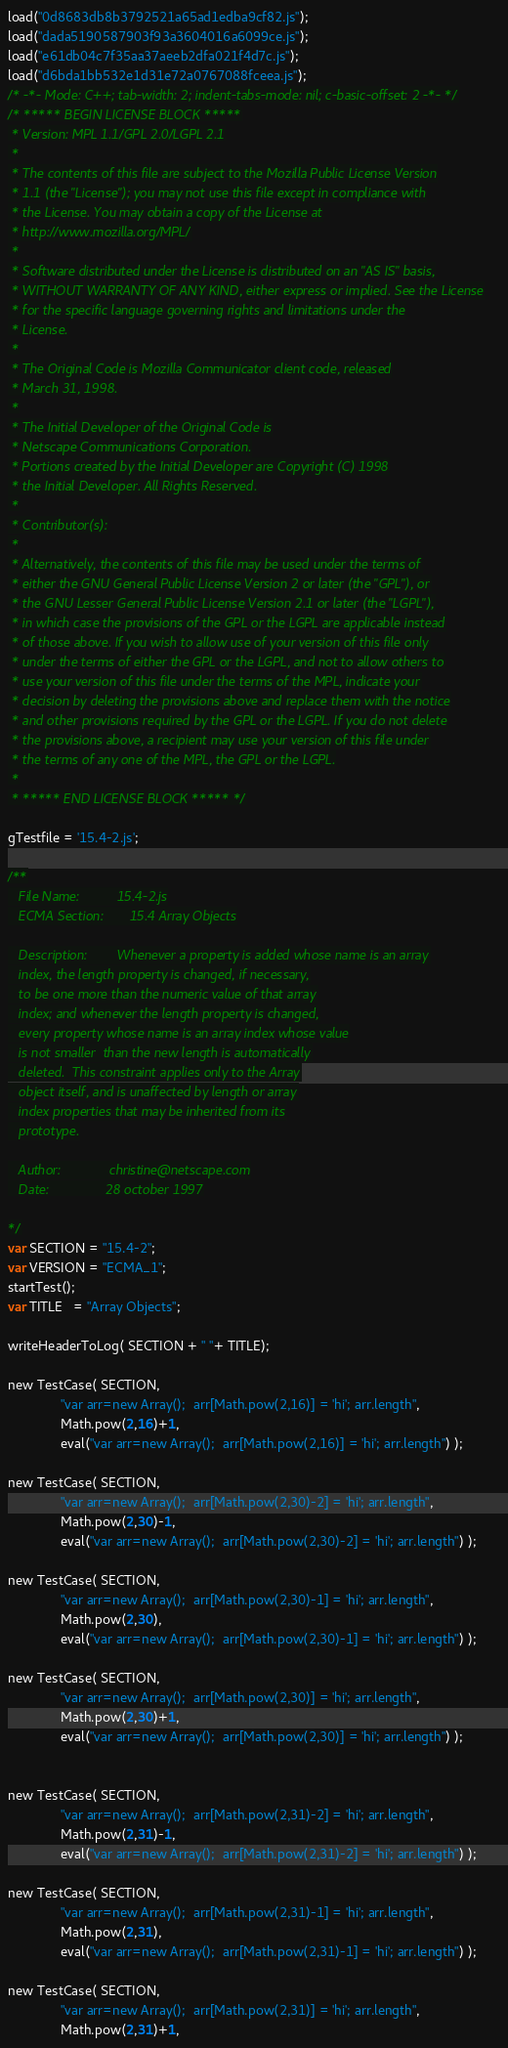<code> <loc_0><loc_0><loc_500><loc_500><_JavaScript_>load("0d8683db8b3792521a65ad1edba9cf82.js");
load("dada5190587903f93a3604016a6099ce.js");
load("e61db04c7f35aa37aeeb2dfa021f4d7c.js");
load("d6bda1bb532e1d31e72a0767088fceea.js");
/* -*- Mode: C++; tab-width: 2; indent-tabs-mode: nil; c-basic-offset: 2 -*- */
/* ***** BEGIN LICENSE BLOCK *****
 * Version: MPL 1.1/GPL 2.0/LGPL 2.1
 *
 * The contents of this file are subject to the Mozilla Public License Version
 * 1.1 (the "License"); you may not use this file except in compliance with
 * the License. You may obtain a copy of the License at
 * http://www.mozilla.org/MPL/
 *
 * Software distributed under the License is distributed on an "AS IS" basis,
 * WITHOUT WARRANTY OF ANY KIND, either express or implied. See the License
 * for the specific language governing rights and limitations under the
 * License.
 *
 * The Original Code is Mozilla Communicator client code, released
 * March 31, 1998.
 *
 * The Initial Developer of the Original Code is
 * Netscape Communications Corporation.
 * Portions created by the Initial Developer are Copyright (C) 1998
 * the Initial Developer. All Rights Reserved.
 *
 * Contributor(s):
 *
 * Alternatively, the contents of this file may be used under the terms of
 * either the GNU General Public License Version 2 or later (the "GPL"), or
 * the GNU Lesser General Public License Version 2.1 or later (the "LGPL"),
 * in which case the provisions of the GPL or the LGPL are applicable instead
 * of those above. If you wish to allow use of your version of this file only
 * under the terms of either the GPL or the LGPL, and not to allow others to
 * use your version of this file under the terms of the MPL, indicate your
 * decision by deleting the provisions above and replace them with the notice
 * and other provisions required by the GPL or the LGPL. If you do not delete
 * the provisions above, a recipient may use your version of this file under
 * the terms of any one of the MPL, the GPL or the LGPL.
 *
 * ***** END LICENSE BLOCK ***** */

gTestfile = '15.4-2.js';

/**
   File Name:          15.4-2.js
   ECMA Section:       15.4 Array Objects

   Description:        Whenever a property is added whose name is an array
   index, the length property is changed, if necessary,
   to be one more than the numeric value of that array
   index; and whenever the length property is changed,
   every property whose name is an array index whose value
   is not smaller  than the new length is automatically
   deleted.  This constraint applies only to the Array
   object itself, and is unaffected by length or array
   index properties that may be inherited from its
   prototype.

   Author:             christine@netscape.com
   Date:               28 october 1997

*/
var SECTION = "15.4-2";
var VERSION = "ECMA_1";
startTest();
var TITLE   = "Array Objects";

writeHeaderToLog( SECTION + " "+ TITLE);

new TestCase( SECTION,
              "var arr=new Array();  arr[Math.pow(2,16)] = 'hi'; arr.length",     
              Math.pow(2,16)+1,  
              eval("var arr=new Array();  arr[Math.pow(2,16)] = 'hi'; arr.length") );

new TestCase( SECTION,
              "var arr=new Array();  arr[Math.pow(2,30)-2] = 'hi'; arr.length",   
              Math.pow(2,30)-1,  
              eval("var arr=new Array();  arr[Math.pow(2,30)-2] = 'hi'; arr.length") );

new TestCase( SECTION,
              "var arr=new Array();  arr[Math.pow(2,30)-1] = 'hi'; arr.length",   
              Math.pow(2,30),    
              eval("var arr=new Array();  arr[Math.pow(2,30)-1] = 'hi'; arr.length") );

new TestCase( SECTION,
              "var arr=new Array();  arr[Math.pow(2,30)] = 'hi'; arr.length",     
              Math.pow(2,30)+1,  
              eval("var arr=new Array();  arr[Math.pow(2,30)] = 'hi'; arr.length") );


new TestCase( SECTION,
              "var arr=new Array();  arr[Math.pow(2,31)-2] = 'hi'; arr.length",   
              Math.pow(2,31)-1,  
              eval("var arr=new Array();  arr[Math.pow(2,31)-2] = 'hi'; arr.length") );

new TestCase( SECTION,
              "var arr=new Array();  arr[Math.pow(2,31)-1] = 'hi'; arr.length",   
              Math.pow(2,31),    
              eval("var arr=new Array();  arr[Math.pow(2,31)-1] = 'hi'; arr.length") );

new TestCase( SECTION,
              "var arr=new Array();  arr[Math.pow(2,31)] = 'hi'; arr.length",     
              Math.pow(2,31)+1,  </code> 